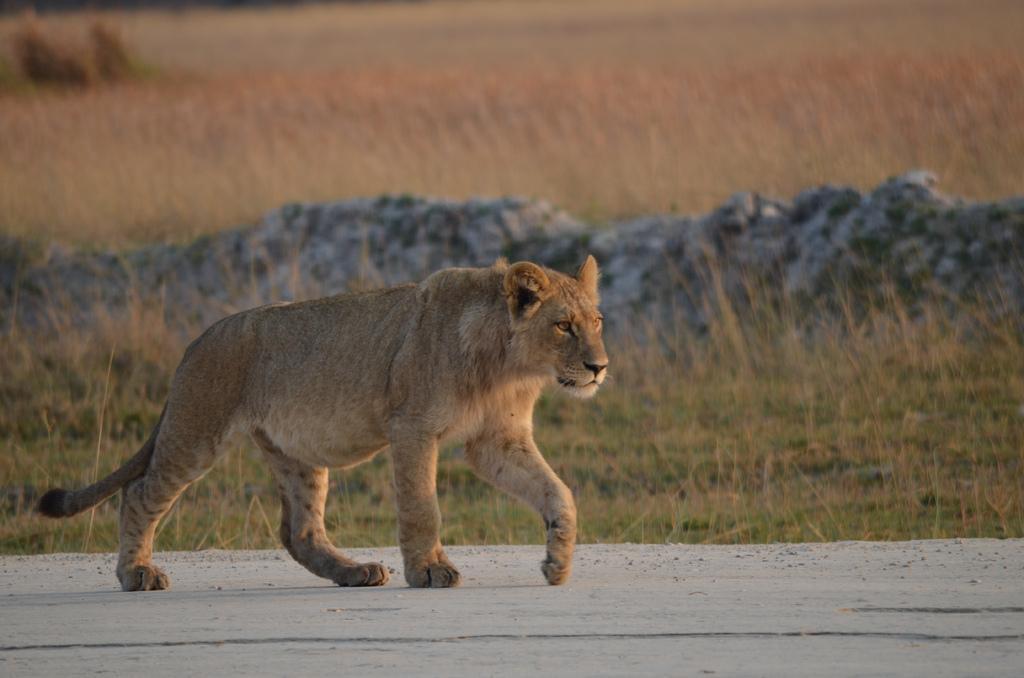In one or two sentences, can you explain what this image depicts? This picture contains tiger which is walking on the road. Beside that, we see grass and rocks. In the background, we see dry grass and it is blurred. This picture might be clicked in a zoo. 